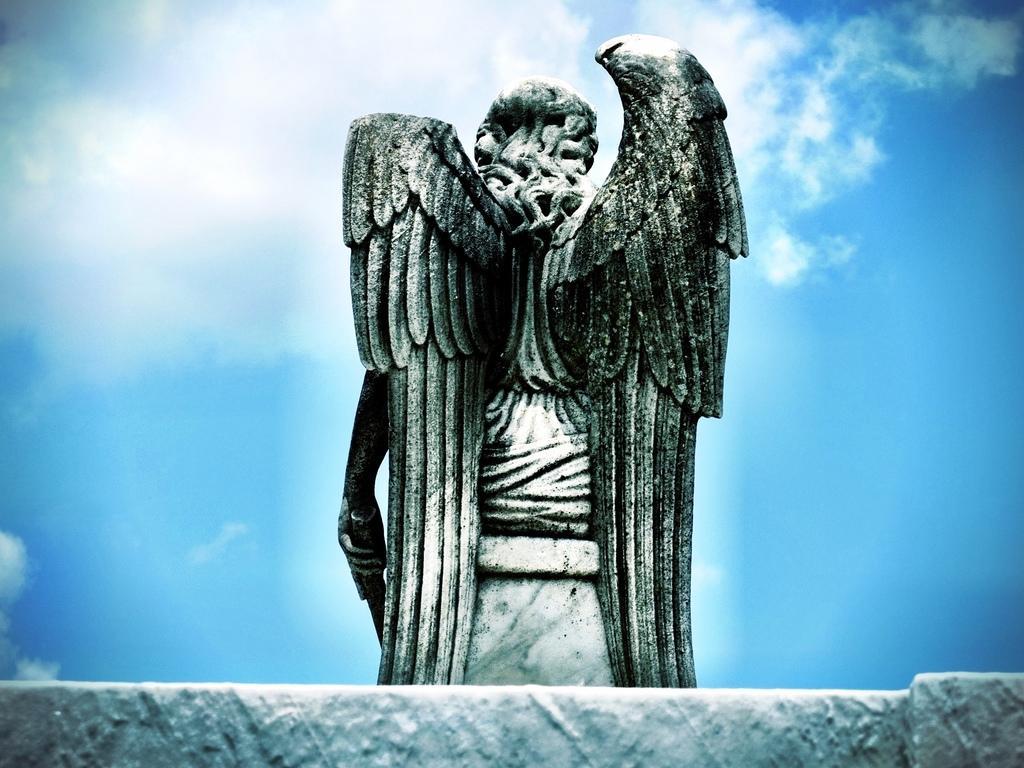Please provide a concise description of this image. In the image there is a statue of an angel in the front and above its sky with clouds. 